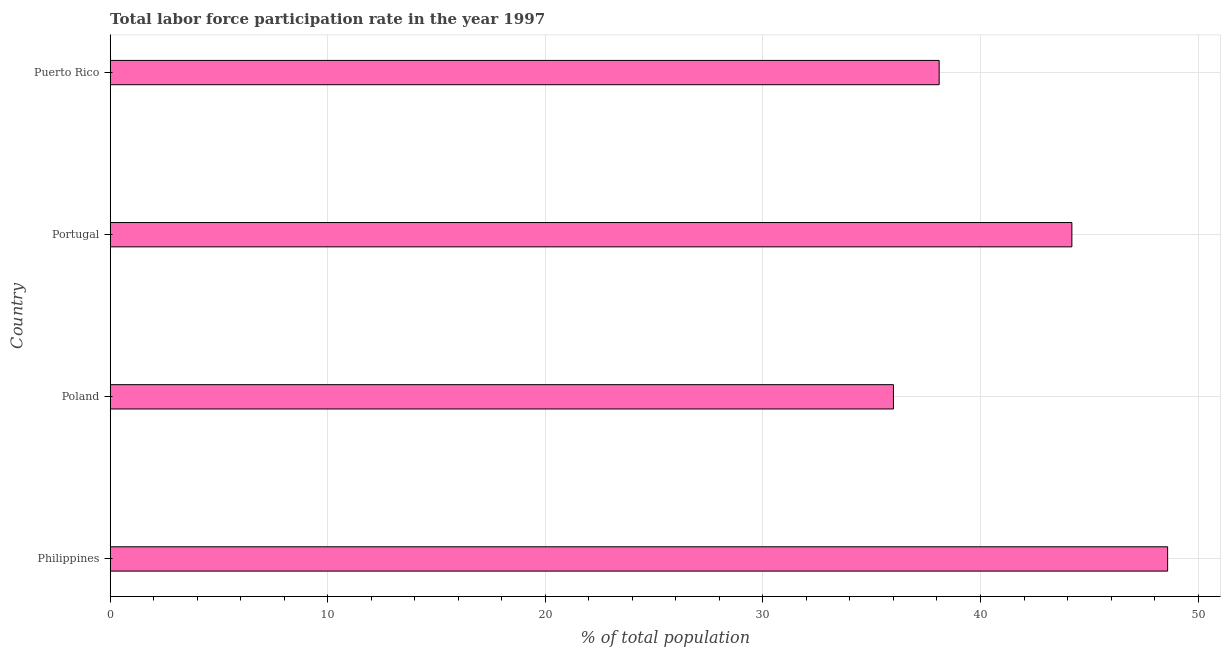Does the graph contain any zero values?
Your response must be concise. No. Does the graph contain grids?
Your response must be concise. Yes. What is the title of the graph?
Provide a succinct answer. Total labor force participation rate in the year 1997. What is the label or title of the X-axis?
Make the answer very short. % of total population. What is the label or title of the Y-axis?
Keep it short and to the point. Country. What is the total labor force participation rate in Poland?
Make the answer very short. 36. Across all countries, what is the maximum total labor force participation rate?
Your answer should be very brief. 48.6. In which country was the total labor force participation rate maximum?
Make the answer very short. Philippines. What is the sum of the total labor force participation rate?
Your response must be concise. 166.9. What is the difference between the total labor force participation rate in Poland and Puerto Rico?
Provide a short and direct response. -2.1. What is the average total labor force participation rate per country?
Your answer should be very brief. 41.73. What is the median total labor force participation rate?
Keep it short and to the point. 41.15. In how many countries, is the total labor force participation rate greater than 10 %?
Provide a short and direct response. 4. What is the ratio of the total labor force participation rate in Poland to that in Puerto Rico?
Keep it short and to the point. 0.94. Is the difference between the total labor force participation rate in Poland and Puerto Rico greater than the difference between any two countries?
Provide a short and direct response. No. Is the sum of the total labor force participation rate in Philippines and Portugal greater than the maximum total labor force participation rate across all countries?
Keep it short and to the point. Yes. What is the difference between the highest and the lowest total labor force participation rate?
Your answer should be compact. 12.6. How many countries are there in the graph?
Make the answer very short. 4. What is the % of total population in Philippines?
Offer a very short reply. 48.6. What is the % of total population of Poland?
Your answer should be compact. 36. What is the % of total population in Portugal?
Provide a short and direct response. 44.2. What is the % of total population in Puerto Rico?
Offer a terse response. 38.1. What is the difference between the % of total population in Philippines and Poland?
Offer a terse response. 12.6. What is the difference between the % of total population in Philippines and Portugal?
Offer a terse response. 4.4. What is the difference between the % of total population in Philippines and Puerto Rico?
Give a very brief answer. 10.5. What is the difference between the % of total population in Poland and Puerto Rico?
Your response must be concise. -2.1. What is the difference between the % of total population in Portugal and Puerto Rico?
Provide a succinct answer. 6.1. What is the ratio of the % of total population in Philippines to that in Poland?
Give a very brief answer. 1.35. What is the ratio of the % of total population in Philippines to that in Puerto Rico?
Ensure brevity in your answer.  1.28. What is the ratio of the % of total population in Poland to that in Portugal?
Offer a terse response. 0.81. What is the ratio of the % of total population in Poland to that in Puerto Rico?
Your answer should be very brief. 0.94. What is the ratio of the % of total population in Portugal to that in Puerto Rico?
Your response must be concise. 1.16. 